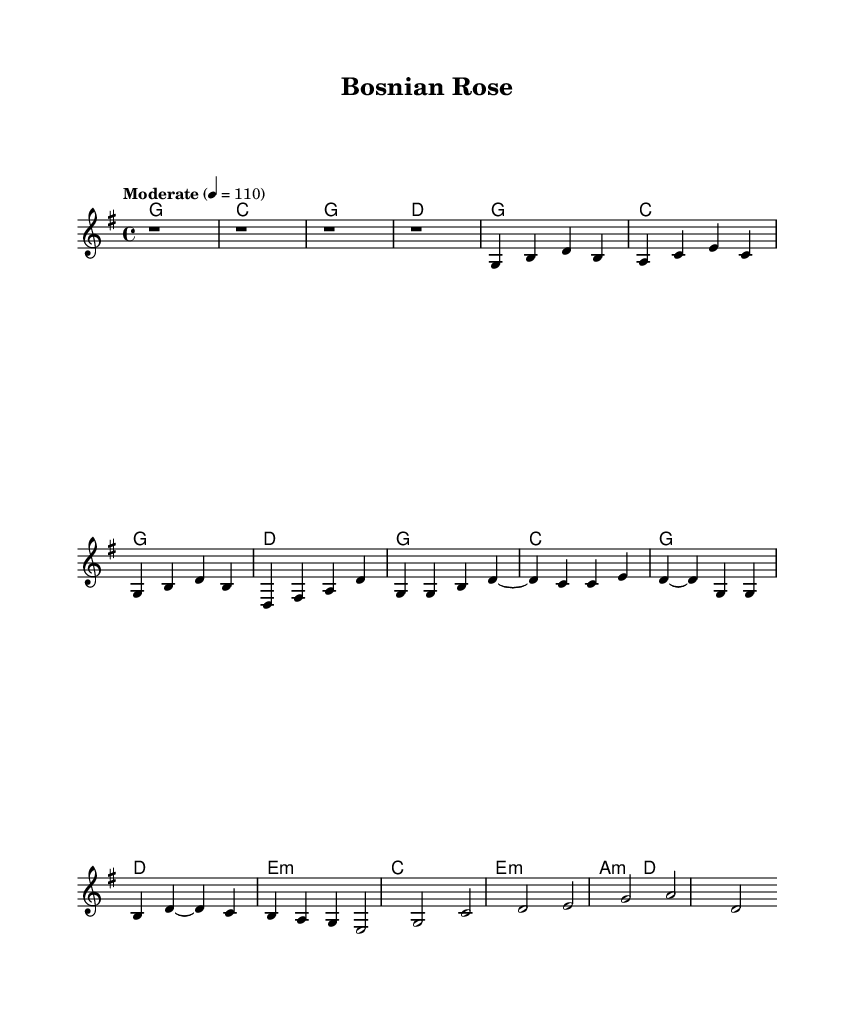What is the key signature of this music? The key signature is G major, which has one sharp (F#). You can determine this by looking at the starting note and the key of the song indicated.
Answer: G major What is the time signature of this piece? The time signature is 4/4, meaning there are four beats in each measure and each quarter note gets one beat. This can be seen at the beginning of the sheet music.
Answer: 4/4 What is the tempo marking given for this music? The tempo marking provided is "Moderate," with the metronome marking being 4 = 110, indicating a moderate pace. This is noted at the starting of the score under the tempo indication.
Answer: Moderate 4 = 110 How many sections are there in this music? The music consists of three distinct sections: Verse, Chorus, and Bridge. This can be identified by the structure shown in the melody and harmonies, indicating different parts of the song.
Answer: Three Which chord appears most frequently in the piece? The chord G major appears most frequently, as it is the root chord of the key and is used in the introduction, verse, and chorus parts consistently. This can be verified by counting the occurrences in the harmonies.
Answer: G What is the first note of the melody? The first note of the melody is G. This can be found by looking at the melody line where it begins, implying the starting pitch.
Answer: G Which musical form is primarily used in this piece? The musical form is likely a verse-chorus structure, which is common in country music. This can be deduced from the specific sections labeled and the repetition typical in this genre.
Answer: Verse-chorus 